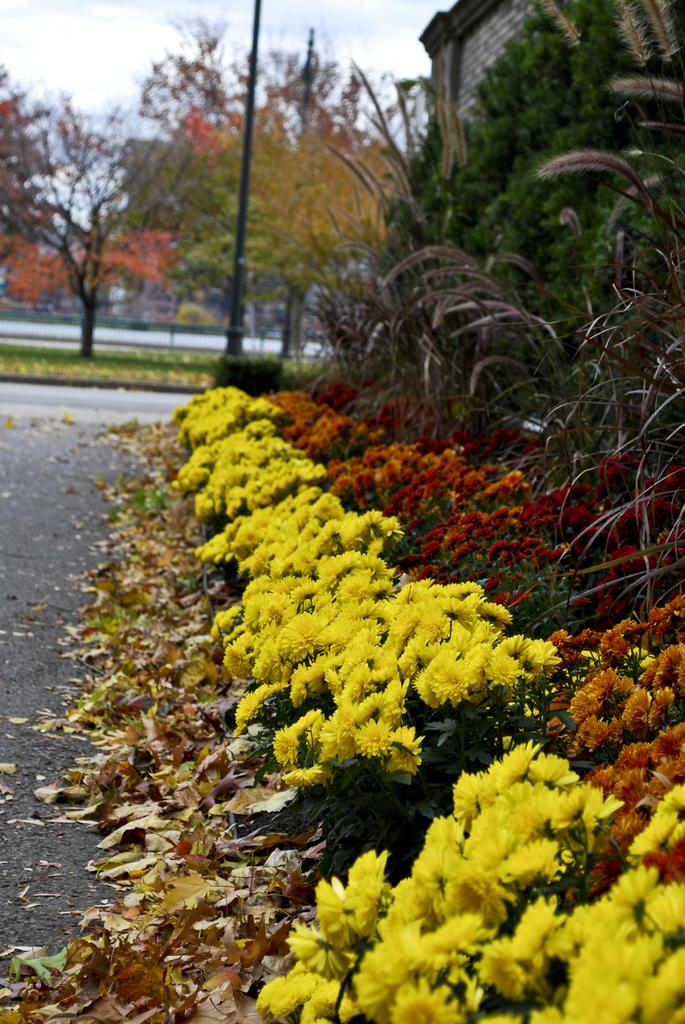What type of plants can be seen in the image? There are plants with flowers in the image. What other vegetation is present in the image? There are trees in the image. What part of the plants is visible in the image? Leaves are present in the image. What man-made structure can be seen in the image? There is a pole in the image. What type of pathway is visible in the image? There is a road in the image. What architectural feature is present in the image? There is a wall in the image. What can be seen in the background of the image? The sky is visible in the background of the image. How does the food increase in size in the image? There is no food present in the image, so it cannot increase in size. What type of space vehicle can be seen in the image? There is no space vehicle present in the image; it features plants, trees, and other earthly elements. 